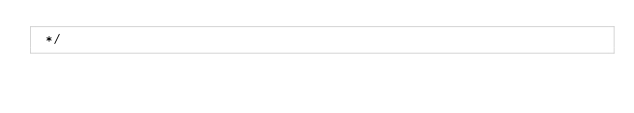Convert code to text. <code><loc_0><loc_0><loc_500><loc_500><_C_> */

</code> 